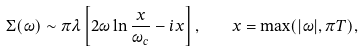Convert formula to latex. <formula><loc_0><loc_0><loc_500><loc_500>\Sigma ( \omega ) \sim \pi \lambda \left [ 2 \omega \ln \frac { x } { \omega _ { c } } - i x \right ] , \quad x = \max ( | \omega | , \pi T ) ,</formula> 